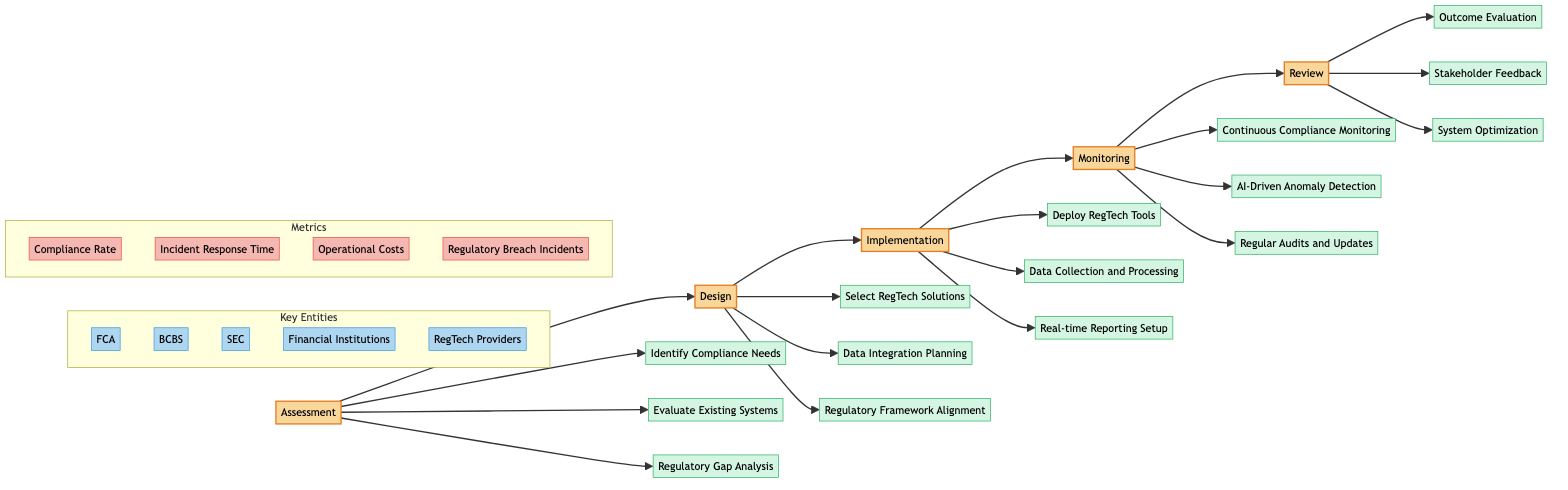What is the first stage in the Clinical Pathway? The first stage listed in the diagram is "Assessment," which is identified at the top of the flowchart connecting to the subsequent stages.
Answer: Assessment How many key entities are present in this Clinical Pathway? There are five key entities in the diagram: FCA, BCBS, SEC, Financial Institutions, and RegTech Providers, which are grouped in their own subgraph.
Answer: 5 What element follows "Deploy RegTech Tools" in the Implementation stage? The next element in the Implementation stage, following "Deploy RegTech Tools," is "Data Collection and Processing," which is connected directly below it in the diagram.
Answer: Data Collection and Processing Which stage includes "AI-Driven Anomaly Detection"? "AI-Driven Anomaly Detection" is an element in the Monitoring stage, as indicated by its direct connection under that stage in the flowchart.
Answer: Monitoring What is the last element in the Review stage? The last element listed in the Review stage is "System Optimization," which appears at the bottom of its respective section.
Answer: System Optimization What is the primary purpose of "Regulatory Gap Analysis"? "Regulatory Gap Analysis" is part of the Assessment stage and refers to identifying any inadequacies in compliance with current regulations, as indicated in the elements within that stage.
Answer: Identify inadequacies How many elements are in the Monitoring stage? The Monitoring stage contains three elements: Continuous Compliance Monitoring, AI-Driven Anomaly Detection, and Regular Audits and Updates, as shown directly under that stage.
Answer: 3 Which metric measures the efficiency of response to compliance incidents? "Incident Response Time" is the metric that measures how efficiently responses to compliance incidents are handled, which is associated with the metrics subgraph in the diagram.
Answer: Incident Response Time What does the Design stage emphasize regarding RegTech solutions? The Design stage emphasizes "Select RegTech Solutions," which directly underlines the importance of choosing appropriate technology to meet compliance needs outlined in the prior Assessment stage.
Answer: Select RegTech Solutions 